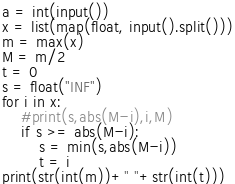<code> <loc_0><loc_0><loc_500><loc_500><_Python_>a = int(input())
x = list(map(float, input().split()))
m = max(x)
M = m/2
t = 0
s = float("INF")
for i in x:
    #print(s,abs(M-i),i,M)
    if s >= abs(M-i):
        s = min(s,abs(M-i))
        t = i
print(str(int(m))+" "+str(int(t)))</code> 